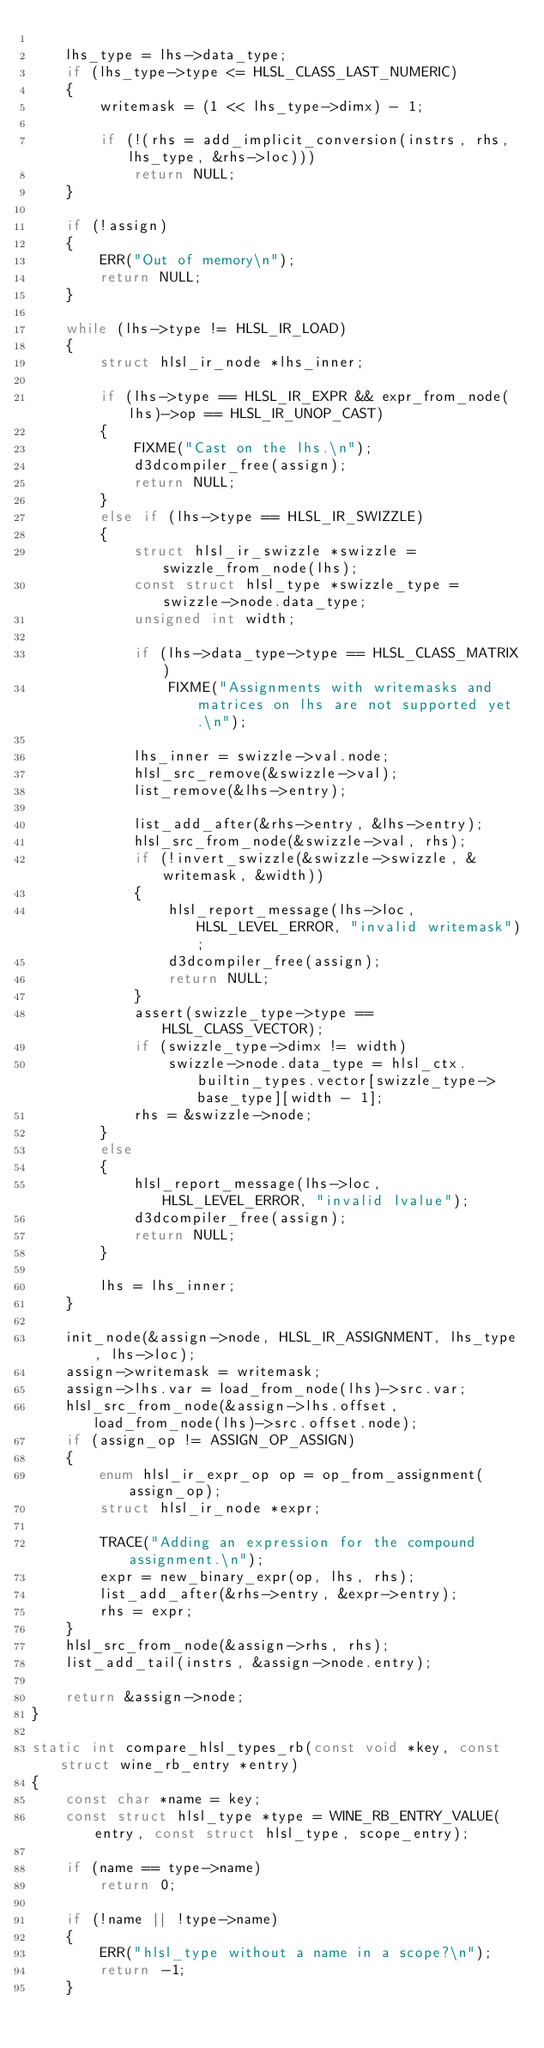Convert code to text. <code><loc_0><loc_0><loc_500><loc_500><_C_>
    lhs_type = lhs->data_type;
    if (lhs_type->type <= HLSL_CLASS_LAST_NUMERIC)
    {
        writemask = (1 << lhs_type->dimx) - 1;

        if (!(rhs = add_implicit_conversion(instrs, rhs, lhs_type, &rhs->loc)))
            return NULL;
    }

    if (!assign)
    {
        ERR("Out of memory\n");
        return NULL;
    }

    while (lhs->type != HLSL_IR_LOAD)
    {
        struct hlsl_ir_node *lhs_inner;

        if (lhs->type == HLSL_IR_EXPR && expr_from_node(lhs)->op == HLSL_IR_UNOP_CAST)
        {
            FIXME("Cast on the lhs.\n");
            d3dcompiler_free(assign);
            return NULL;
        }
        else if (lhs->type == HLSL_IR_SWIZZLE)
        {
            struct hlsl_ir_swizzle *swizzle = swizzle_from_node(lhs);
            const struct hlsl_type *swizzle_type = swizzle->node.data_type;
            unsigned int width;

            if (lhs->data_type->type == HLSL_CLASS_MATRIX)
                FIXME("Assignments with writemasks and matrices on lhs are not supported yet.\n");

            lhs_inner = swizzle->val.node;
            hlsl_src_remove(&swizzle->val);
            list_remove(&lhs->entry);

            list_add_after(&rhs->entry, &lhs->entry);
            hlsl_src_from_node(&swizzle->val, rhs);
            if (!invert_swizzle(&swizzle->swizzle, &writemask, &width))
            {
                hlsl_report_message(lhs->loc, HLSL_LEVEL_ERROR, "invalid writemask");
                d3dcompiler_free(assign);
                return NULL;
            }
            assert(swizzle_type->type == HLSL_CLASS_VECTOR);
            if (swizzle_type->dimx != width)
                swizzle->node.data_type = hlsl_ctx.builtin_types.vector[swizzle_type->base_type][width - 1];
            rhs = &swizzle->node;
        }
        else
        {
            hlsl_report_message(lhs->loc, HLSL_LEVEL_ERROR, "invalid lvalue");
            d3dcompiler_free(assign);
            return NULL;
        }

        lhs = lhs_inner;
    }

    init_node(&assign->node, HLSL_IR_ASSIGNMENT, lhs_type, lhs->loc);
    assign->writemask = writemask;
    assign->lhs.var = load_from_node(lhs)->src.var;
    hlsl_src_from_node(&assign->lhs.offset, load_from_node(lhs)->src.offset.node);
    if (assign_op != ASSIGN_OP_ASSIGN)
    {
        enum hlsl_ir_expr_op op = op_from_assignment(assign_op);
        struct hlsl_ir_node *expr;

        TRACE("Adding an expression for the compound assignment.\n");
        expr = new_binary_expr(op, lhs, rhs);
        list_add_after(&rhs->entry, &expr->entry);
        rhs = expr;
    }
    hlsl_src_from_node(&assign->rhs, rhs);
    list_add_tail(instrs, &assign->node.entry);

    return &assign->node;
}

static int compare_hlsl_types_rb(const void *key, const struct wine_rb_entry *entry)
{
    const char *name = key;
    const struct hlsl_type *type = WINE_RB_ENTRY_VALUE(entry, const struct hlsl_type, scope_entry);

    if (name == type->name)
        return 0;

    if (!name || !type->name)
    {
        ERR("hlsl_type without a name in a scope?\n");
        return -1;
    }</code> 